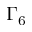Convert formula to latex. <formula><loc_0><loc_0><loc_500><loc_500>\Gamma _ { 6 }</formula> 